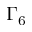Convert formula to latex. <formula><loc_0><loc_0><loc_500><loc_500>\Gamma _ { 6 }</formula> 